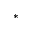<formula> <loc_0><loc_0><loc_500><loc_500>^ { \ast }</formula> 